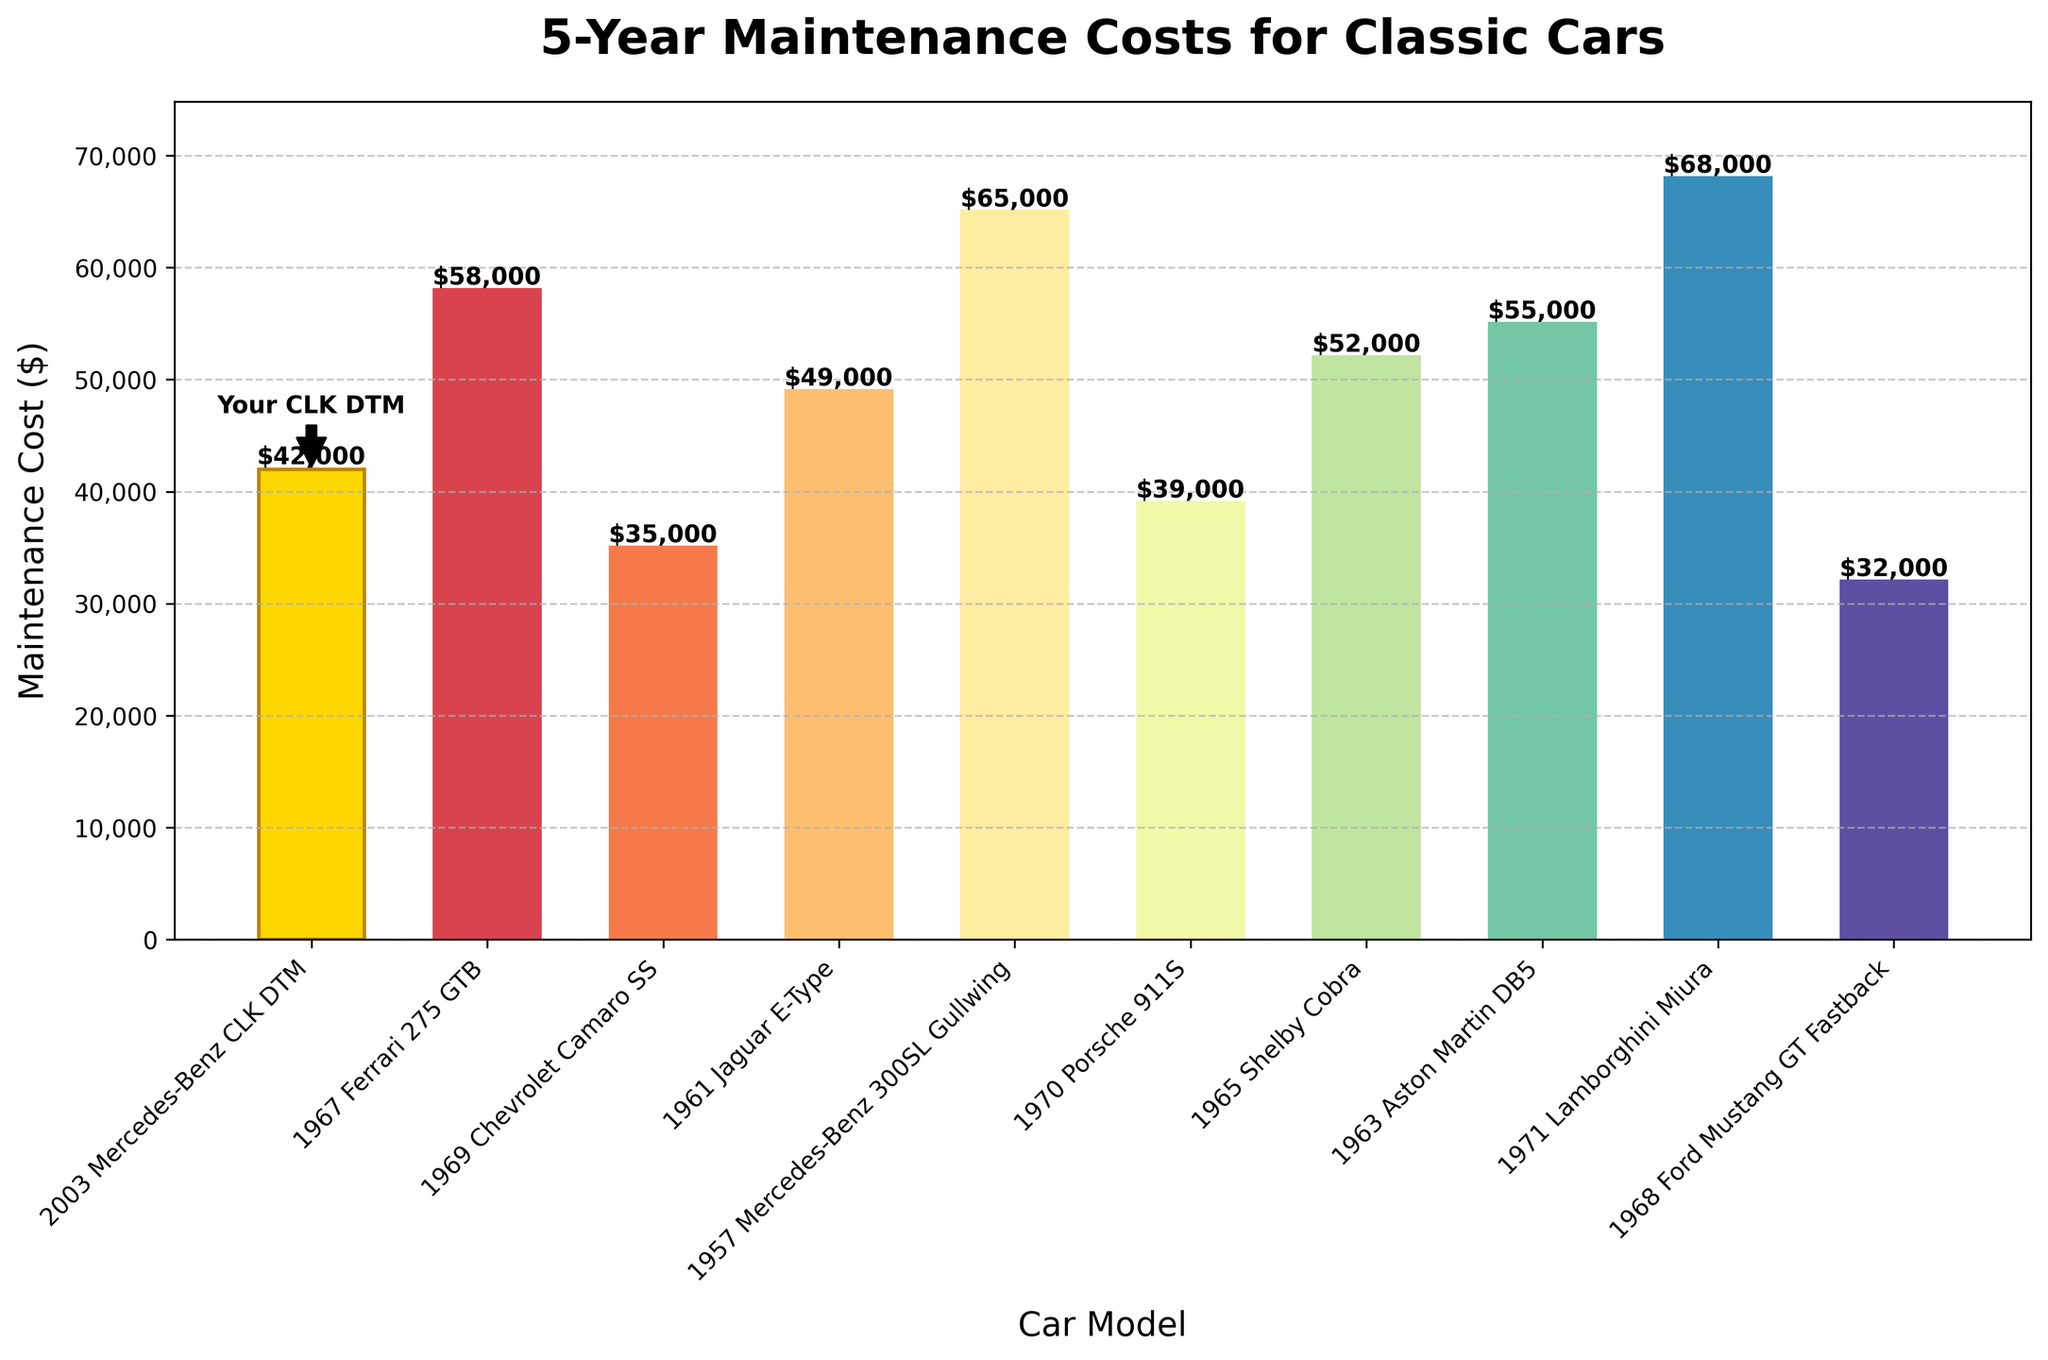What's the 5-year maintenance cost of the most expensive car model? The most expensive car model, according to the plot, is the 1971 Lamborghini Miura. By looking at the height of its bar, we see that the 5-year maintenance cost is $68,000.
Answer: $68,000 Which car model has the lowest 5-year maintenance cost? By examining the shortest bar in the chart, the 1968 Ford Mustang GT Fastback has the lowest 5-year maintenance cost of $32,000.
Answer: $32,000 How much more is the 5-year maintenance cost of the 1957 Mercedes-Benz 300SL Gullwing compared to the 2003 Mercedes-Benz CLK DTM? The 5-year maintenance cost of the 1957 Mercedes-Benz 300SL Gullwing is $65,000, and the 2003 Mercedes-Benz CLK DTM is $42,000. The difference is $65,000 - $42,000 = $23,000.
Answer: $23,000 What's the average 5-year maintenance cost for all the classic cars listed? Sum all the 5-year maintenance costs and divide by the number of car models: (42,000 + 58,000 + 35,000 + 49,000 + 65,000 + 39,000 + 52,000 + 55,000 + 68,000 + 32,000) / 10 = 49,500.
Answer: $49,500 Which car models have a 5-year maintenance cost greater than $50,000 but less than $60,000? From the bar chart, the car models that fall within this range are the 1967 Ferrari 275 GTB, the 1965 Shelby Cobra, and the 1963 Aston Martin DB5. Their bars fall between $50,000 and $60,000.
Answer: 1967 Ferrari 275 GTB, 1965 Shelby Cobra, 1963 Aston Martin DB5 What are the colors of the bars representing the most and least expensive car models? The bar representing the 1971 Lamborghini Miura (most expensive) is depicted with a distinctive color from the Spectral color map, and the bar for the 1968 Ford Mustang GT Fastback (least expensive) is another distinct color from the same color map.
Answer: Unique colors per Spectral colormap Which car models have a maintenance cost bar height roughly equal to the bar height for your 2003 Mercedes-Benz CLK DTM? By comparing the heights of the bars, the 1969 Chevrolet Camaro SS ($35,000) and 1968 Ford Mustang GT Fastback ($32,000) have maintenance costs closest to the 2003 Mercedes-Benz CLK DTM ($42,000).
Answer: 1969 Chevrolet Camaro SS, 1968 Ford Mustang GT Fastback What is the difference in the 5-year maintenance cost between the 1965 Shelby Cobra and the 1970 Porsche 911S? From the chart, the 5-year maintenance cost for the 1965 Shelby Cobra is $52,000 and for the 1970 Porsche 911S is $39,000, making the difference $52,000 - $39,000 = $13,000.
Answer: $13,000 